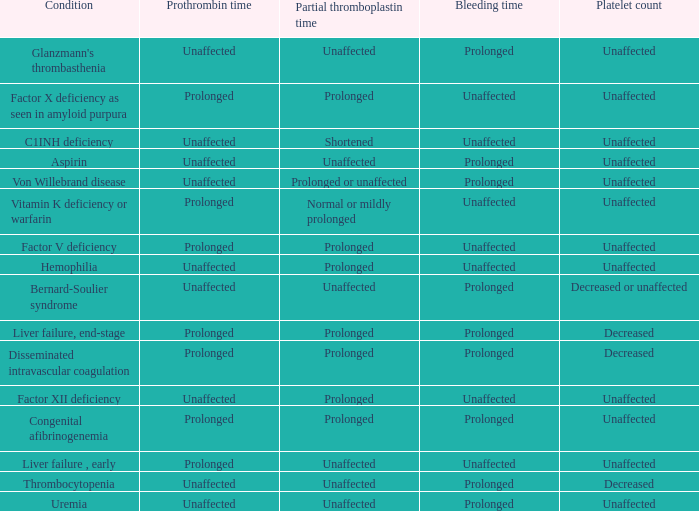Which Condition has an unaffected Partial thromboplastin time, Platelet count, and a Prothrombin time? Aspirin, Uremia, Glanzmann's thrombasthenia. 